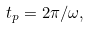<formula> <loc_0><loc_0><loc_500><loc_500>t _ { p } = 2 \pi / \omega ,</formula> 